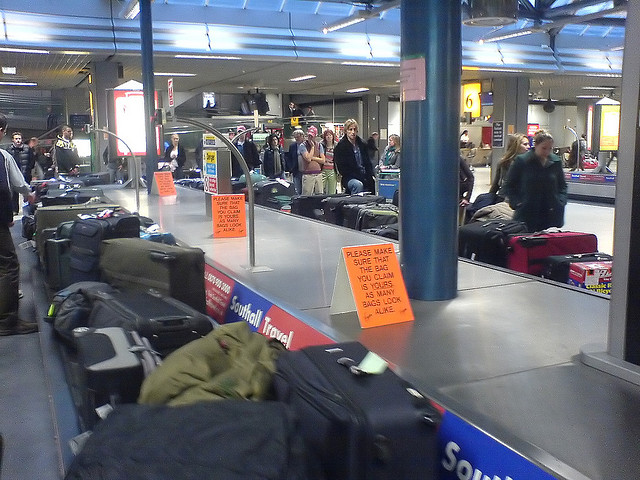<image>What does the first sign say? I don't know what the first sign says. What does the first sign say? I don't know what the first sign says. 